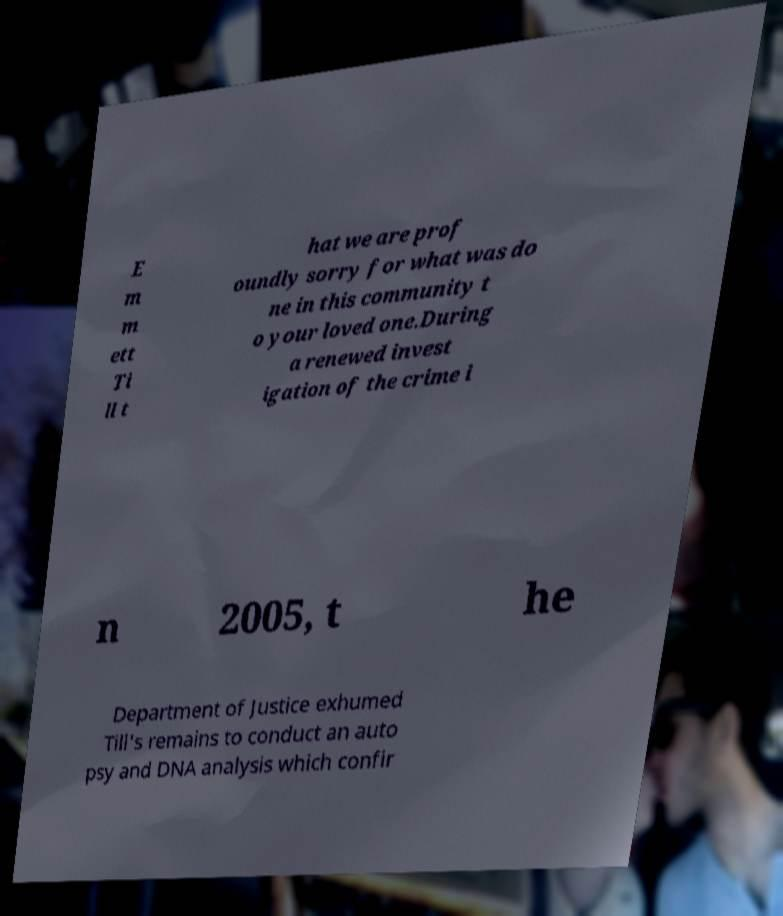Can you accurately transcribe the text from the provided image for me? E m m ett Ti ll t hat we are prof oundly sorry for what was do ne in this community t o your loved one.During a renewed invest igation of the crime i n 2005, t he Department of Justice exhumed Till's remains to conduct an auto psy and DNA analysis which confir 